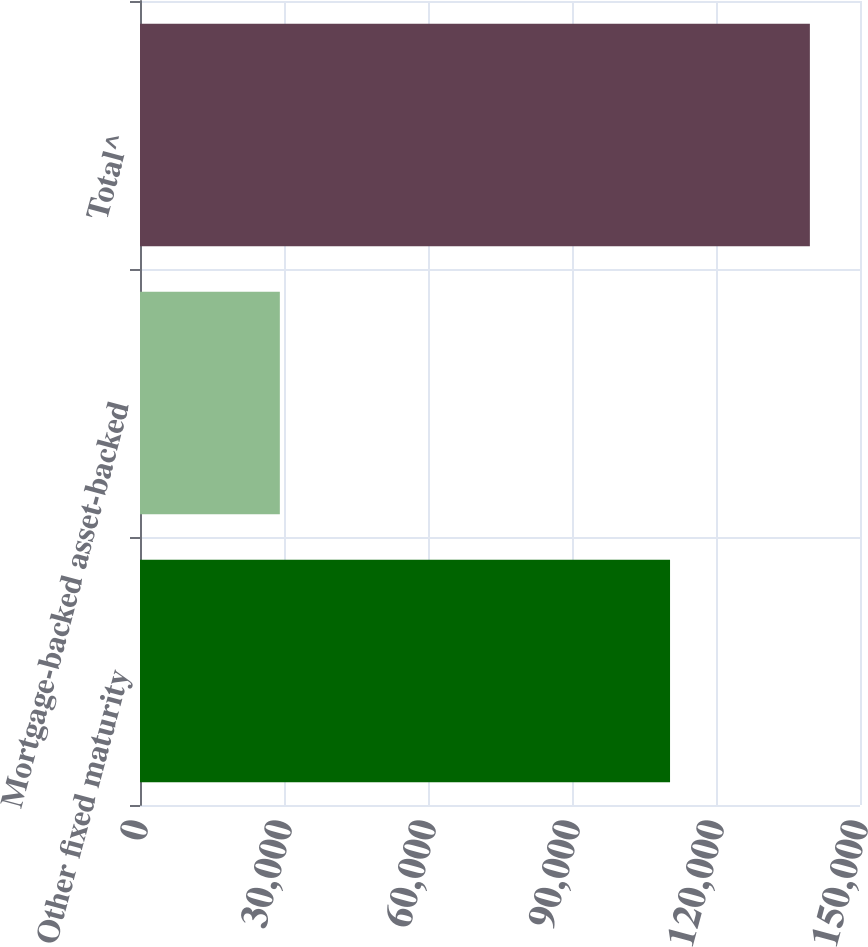Convert chart to OTSL. <chart><loc_0><loc_0><loc_500><loc_500><bar_chart><fcel>Other fixed maturity<fcel>Mortgage-backed asset-backed<fcel>Total^<nl><fcel>110425<fcel>29133<fcel>139558<nl></chart> 